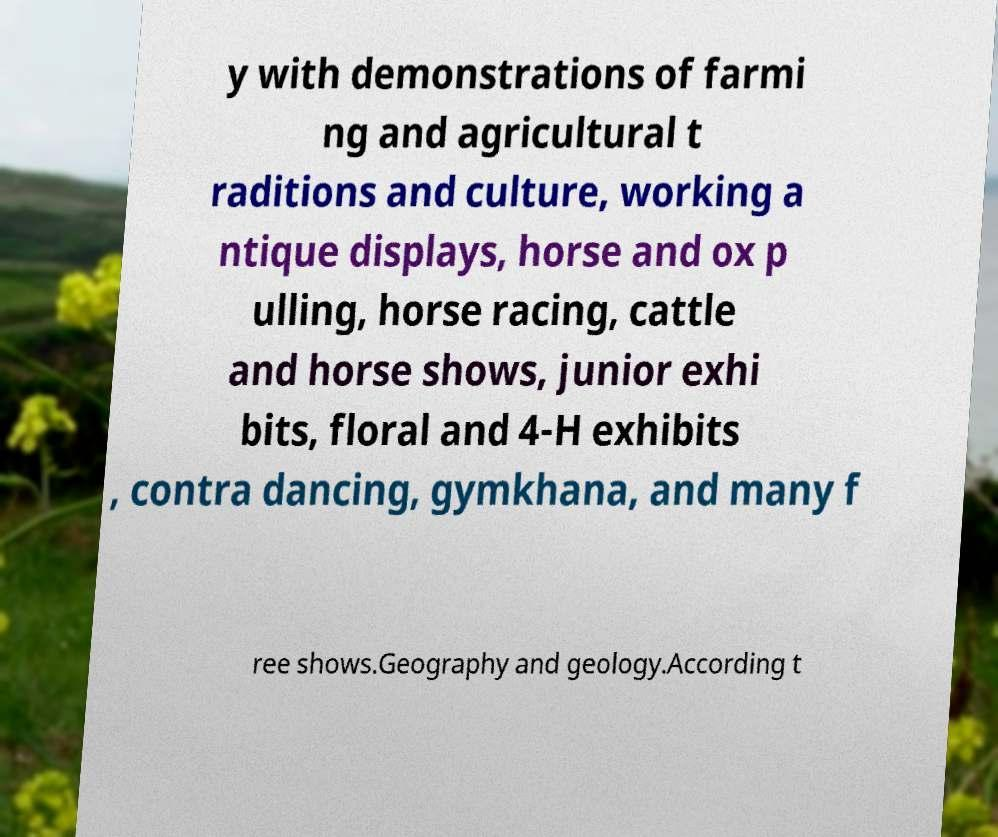Could you extract and type out the text from this image? y with demonstrations of farmi ng and agricultural t raditions and culture, working a ntique displays, horse and ox p ulling, horse racing, cattle and horse shows, junior exhi bits, floral and 4-H exhibits , contra dancing, gymkhana, and many f ree shows.Geography and geology.According t 